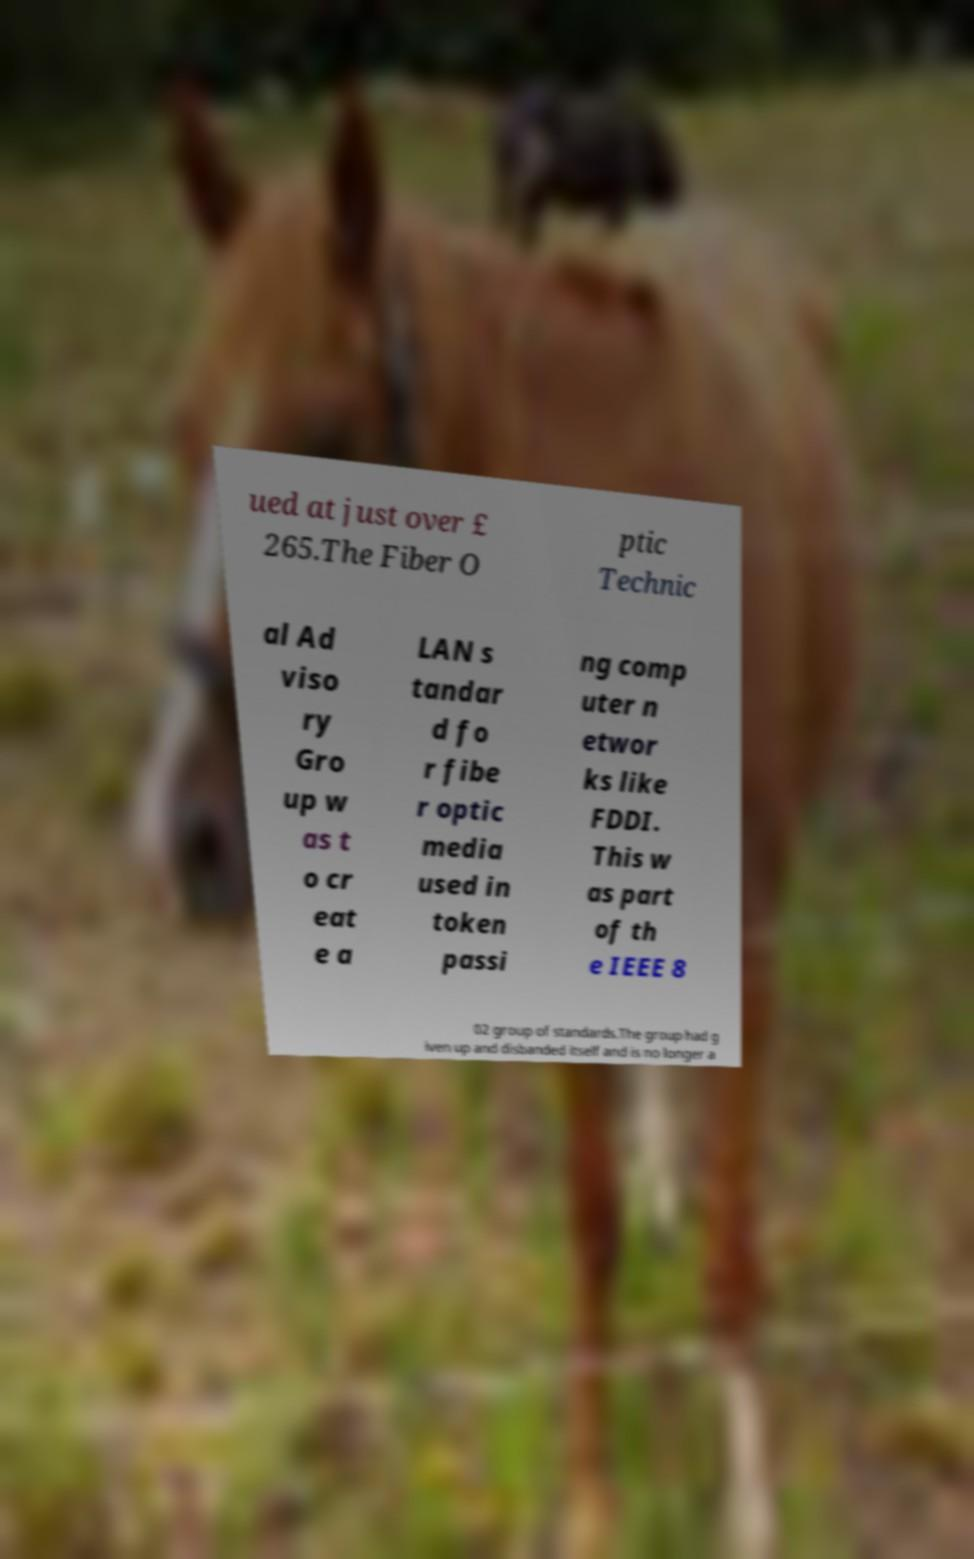Can you accurately transcribe the text from the provided image for me? ued at just over £ 265.The Fiber O ptic Technic al Ad viso ry Gro up w as t o cr eat e a LAN s tandar d fo r fibe r optic media used in token passi ng comp uter n etwor ks like FDDI. This w as part of th e IEEE 8 02 group of standards.The group had g iven up and disbanded itself and is no longer a 